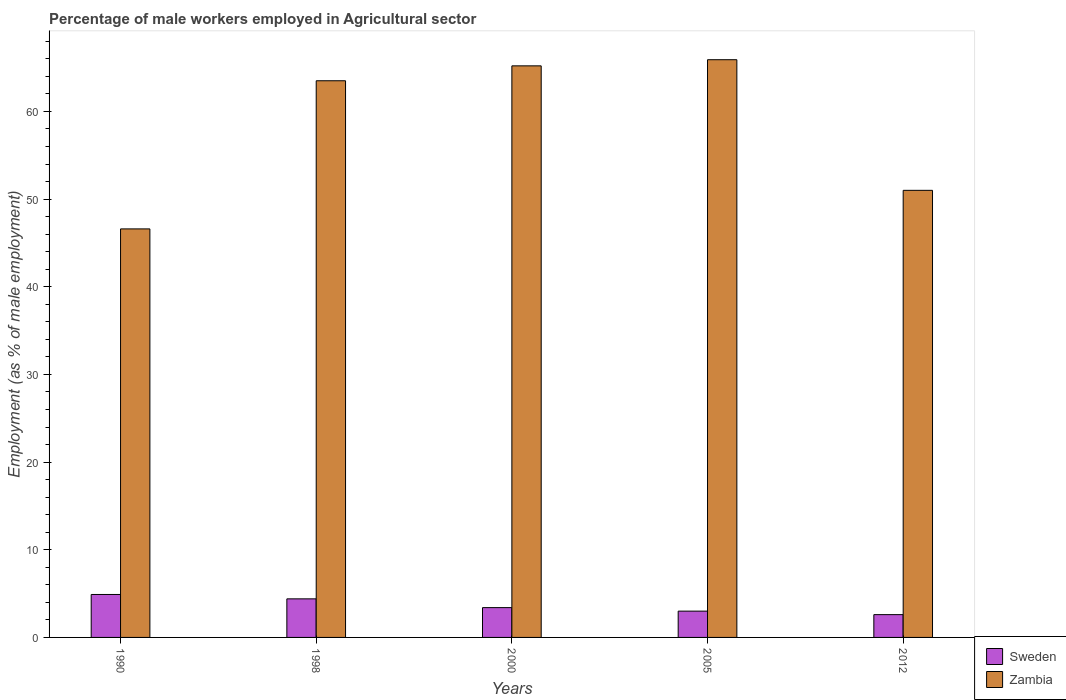How many different coloured bars are there?
Keep it short and to the point. 2. Are the number of bars per tick equal to the number of legend labels?
Your answer should be compact. Yes. Are the number of bars on each tick of the X-axis equal?
Your answer should be compact. Yes. How many bars are there on the 4th tick from the left?
Provide a succinct answer. 2. What is the label of the 5th group of bars from the left?
Offer a very short reply. 2012. In how many cases, is the number of bars for a given year not equal to the number of legend labels?
Give a very brief answer. 0. What is the percentage of male workers employed in Agricultural sector in Sweden in 2012?
Make the answer very short. 2.6. Across all years, what is the maximum percentage of male workers employed in Agricultural sector in Sweden?
Offer a very short reply. 4.9. Across all years, what is the minimum percentage of male workers employed in Agricultural sector in Zambia?
Keep it short and to the point. 46.6. In which year was the percentage of male workers employed in Agricultural sector in Zambia minimum?
Offer a very short reply. 1990. What is the total percentage of male workers employed in Agricultural sector in Zambia in the graph?
Your answer should be very brief. 292.2. What is the difference between the percentage of male workers employed in Agricultural sector in Sweden in 2000 and that in 2005?
Make the answer very short. 0.4. What is the difference between the percentage of male workers employed in Agricultural sector in Zambia in 2000 and the percentage of male workers employed in Agricultural sector in Sweden in 1990?
Provide a succinct answer. 60.3. What is the average percentage of male workers employed in Agricultural sector in Sweden per year?
Give a very brief answer. 3.66. In the year 1990, what is the difference between the percentage of male workers employed in Agricultural sector in Sweden and percentage of male workers employed in Agricultural sector in Zambia?
Keep it short and to the point. -41.7. What is the ratio of the percentage of male workers employed in Agricultural sector in Zambia in 2005 to that in 2012?
Offer a terse response. 1.29. Is the percentage of male workers employed in Agricultural sector in Sweden in 1990 less than that in 2005?
Offer a terse response. No. Is the difference between the percentage of male workers employed in Agricultural sector in Sweden in 1990 and 2012 greater than the difference between the percentage of male workers employed in Agricultural sector in Zambia in 1990 and 2012?
Offer a terse response. Yes. What is the difference between the highest and the lowest percentage of male workers employed in Agricultural sector in Zambia?
Offer a terse response. 19.3. Is the sum of the percentage of male workers employed in Agricultural sector in Zambia in 1990 and 1998 greater than the maximum percentage of male workers employed in Agricultural sector in Sweden across all years?
Offer a terse response. Yes. What does the 2nd bar from the left in 2012 represents?
Provide a succinct answer. Zambia. What does the 1st bar from the right in 2012 represents?
Give a very brief answer. Zambia. Are all the bars in the graph horizontal?
Keep it short and to the point. No. How many years are there in the graph?
Offer a very short reply. 5. Does the graph contain any zero values?
Ensure brevity in your answer.  No. Does the graph contain grids?
Provide a succinct answer. No. How many legend labels are there?
Your answer should be compact. 2. How are the legend labels stacked?
Keep it short and to the point. Vertical. What is the title of the graph?
Ensure brevity in your answer.  Percentage of male workers employed in Agricultural sector. What is the label or title of the Y-axis?
Your answer should be very brief. Employment (as % of male employment). What is the Employment (as % of male employment) in Sweden in 1990?
Make the answer very short. 4.9. What is the Employment (as % of male employment) of Zambia in 1990?
Your answer should be very brief. 46.6. What is the Employment (as % of male employment) of Sweden in 1998?
Ensure brevity in your answer.  4.4. What is the Employment (as % of male employment) in Zambia in 1998?
Provide a short and direct response. 63.5. What is the Employment (as % of male employment) in Sweden in 2000?
Provide a short and direct response. 3.4. What is the Employment (as % of male employment) of Zambia in 2000?
Keep it short and to the point. 65.2. What is the Employment (as % of male employment) of Zambia in 2005?
Ensure brevity in your answer.  65.9. What is the Employment (as % of male employment) of Sweden in 2012?
Provide a succinct answer. 2.6. Across all years, what is the maximum Employment (as % of male employment) in Sweden?
Provide a short and direct response. 4.9. Across all years, what is the maximum Employment (as % of male employment) in Zambia?
Your response must be concise. 65.9. Across all years, what is the minimum Employment (as % of male employment) in Sweden?
Provide a short and direct response. 2.6. Across all years, what is the minimum Employment (as % of male employment) of Zambia?
Ensure brevity in your answer.  46.6. What is the total Employment (as % of male employment) in Sweden in the graph?
Make the answer very short. 18.3. What is the total Employment (as % of male employment) in Zambia in the graph?
Make the answer very short. 292.2. What is the difference between the Employment (as % of male employment) of Sweden in 1990 and that in 1998?
Provide a succinct answer. 0.5. What is the difference between the Employment (as % of male employment) of Zambia in 1990 and that in 1998?
Give a very brief answer. -16.9. What is the difference between the Employment (as % of male employment) of Zambia in 1990 and that in 2000?
Provide a succinct answer. -18.6. What is the difference between the Employment (as % of male employment) in Zambia in 1990 and that in 2005?
Offer a terse response. -19.3. What is the difference between the Employment (as % of male employment) in Sweden in 1998 and that in 2000?
Your response must be concise. 1. What is the difference between the Employment (as % of male employment) of Sweden in 1998 and that in 2005?
Ensure brevity in your answer.  1.4. What is the difference between the Employment (as % of male employment) of Zambia in 1998 and that in 2005?
Ensure brevity in your answer.  -2.4. What is the difference between the Employment (as % of male employment) of Sweden in 1998 and that in 2012?
Give a very brief answer. 1.8. What is the difference between the Employment (as % of male employment) in Sweden in 2000 and that in 2005?
Offer a very short reply. 0.4. What is the difference between the Employment (as % of male employment) of Zambia in 2000 and that in 2005?
Your answer should be compact. -0.7. What is the difference between the Employment (as % of male employment) in Sweden in 1990 and the Employment (as % of male employment) in Zambia in 1998?
Give a very brief answer. -58.6. What is the difference between the Employment (as % of male employment) of Sweden in 1990 and the Employment (as % of male employment) of Zambia in 2000?
Make the answer very short. -60.3. What is the difference between the Employment (as % of male employment) in Sweden in 1990 and the Employment (as % of male employment) in Zambia in 2005?
Offer a terse response. -61. What is the difference between the Employment (as % of male employment) of Sweden in 1990 and the Employment (as % of male employment) of Zambia in 2012?
Provide a succinct answer. -46.1. What is the difference between the Employment (as % of male employment) of Sweden in 1998 and the Employment (as % of male employment) of Zambia in 2000?
Make the answer very short. -60.8. What is the difference between the Employment (as % of male employment) of Sweden in 1998 and the Employment (as % of male employment) of Zambia in 2005?
Give a very brief answer. -61.5. What is the difference between the Employment (as % of male employment) of Sweden in 1998 and the Employment (as % of male employment) of Zambia in 2012?
Ensure brevity in your answer.  -46.6. What is the difference between the Employment (as % of male employment) of Sweden in 2000 and the Employment (as % of male employment) of Zambia in 2005?
Your answer should be compact. -62.5. What is the difference between the Employment (as % of male employment) in Sweden in 2000 and the Employment (as % of male employment) in Zambia in 2012?
Your answer should be compact. -47.6. What is the difference between the Employment (as % of male employment) in Sweden in 2005 and the Employment (as % of male employment) in Zambia in 2012?
Give a very brief answer. -48. What is the average Employment (as % of male employment) of Sweden per year?
Provide a short and direct response. 3.66. What is the average Employment (as % of male employment) in Zambia per year?
Provide a succinct answer. 58.44. In the year 1990, what is the difference between the Employment (as % of male employment) of Sweden and Employment (as % of male employment) of Zambia?
Make the answer very short. -41.7. In the year 1998, what is the difference between the Employment (as % of male employment) in Sweden and Employment (as % of male employment) in Zambia?
Offer a very short reply. -59.1. In the year 2000, what is the difference between the Employment (as % of male employment) of Sweden and Employment (as % of male employment) of Zambia?
Your response must be concise. -61.8. In the year 2005, what is the difference between the Employment (as % of male employment) of Sweden and Employment (as % of male employment) of Zambia?
Ensure brevity in your answer.  -62.9. In the year 2012, what is the difference between the Employment (as % of male employment) in Sweden and Employment (as % of male employment) in Zambia?
Ensure brevity in your answer.  -48.4. What is the ratio of the Employment (as % of male employment) in Sweden in 1990 to that in 1998?
Give a very brief answer. 1.11. What is the ratio of the Employment (as % of male employment) in Zambia in 1990 to that in 1998?
Ensure brevity in your answer.  0.73. What is the ratio of the Employment (as % of male employment) in Sweden in 1990 to that in 2000?
Make the answer very short. 1.44. What is the ratio of the Employment (as % of male employment) in Zambia in 1990 to that in 2000?
Provide a short and direct response. 0.71. What is the ratio of the Employment (as % of male employment) of Sweden in 1990 to that in 2005?
Keep it short and to the point. 1.63. What is the ratio of the Employment (as % of male employment) of Zambia in 1990 to that in 2005?
Give a very brief answer. 0.71. What is the ratio of the Employment (as % of male employment) in Sweden in 1990 to that in 2012?
Provide a succinct answer. 1.88. What is the ratio of the Employment (as % of male employment) of Zambia in 1990 to that in 2012?
Offer a very short reply. 0.91. What is the ratio of the Employment (as % of male employment) of Sweden in 1998 to that in 2000?
Ensure brevity in your answer.  1.29. What is the ratio of the Employment (as % of male employment) of Zambia in 1998 to that in 2000?
Offer a terse response. 0.97. What is the ratio of the Employment (as % of male employment) in Sweden in 1998 to that in 2005?
Provide a short and direct response. 1.47. What is the ratio of the Employment (as % of male employment) of Zambia in 1998 to that in 2005?
Your answer should be very brief. 0.96. What is the ratio of the Employment (as % of male employment) of Sweden in 1998 to that in 2012?
Make the answer very short. 1.69. What is the ratio of the Employment (as % of male employment) in Zambia in 1998 to that in 2012?
Provide a short and direct response. 1.25. What is the ratio of the Employment (as % of male employment) in Sweden in 2000 to that in 2005?
Your response must be concise. 1.13. What is the ratio of the Employment (as % of male employment) in Sweden in 2000 to that in 2012?
Keep it short and to the point. 1.31. What is the ratio of the Employment (as % of male employment) in Zambia in 2000 to that in 2012?
Provide a short and direct response. 1.28. What is the ratio of the Employment (as % of male employment) in Sweden in 2005 to that in 2012?
Your response must be concise. 1.15. What is the ratio of the Employment (as % of male employment) in Zambia in 2005 to that in 2012?
Offer a very short reply. 1.29. What is the difference between the highest and the second highest Employment (as % of male employment) of Sweden?
Offer a very short reply. 0.5. What is the difference between the highest and the lowest Employment (as % of male employment) of Sweden?
Provide a succinct answer. 2.3. What is the difference between the highest and the lowest Employment (as % of male employment) in Zambia?
Your answer should be compact. 19.3. 